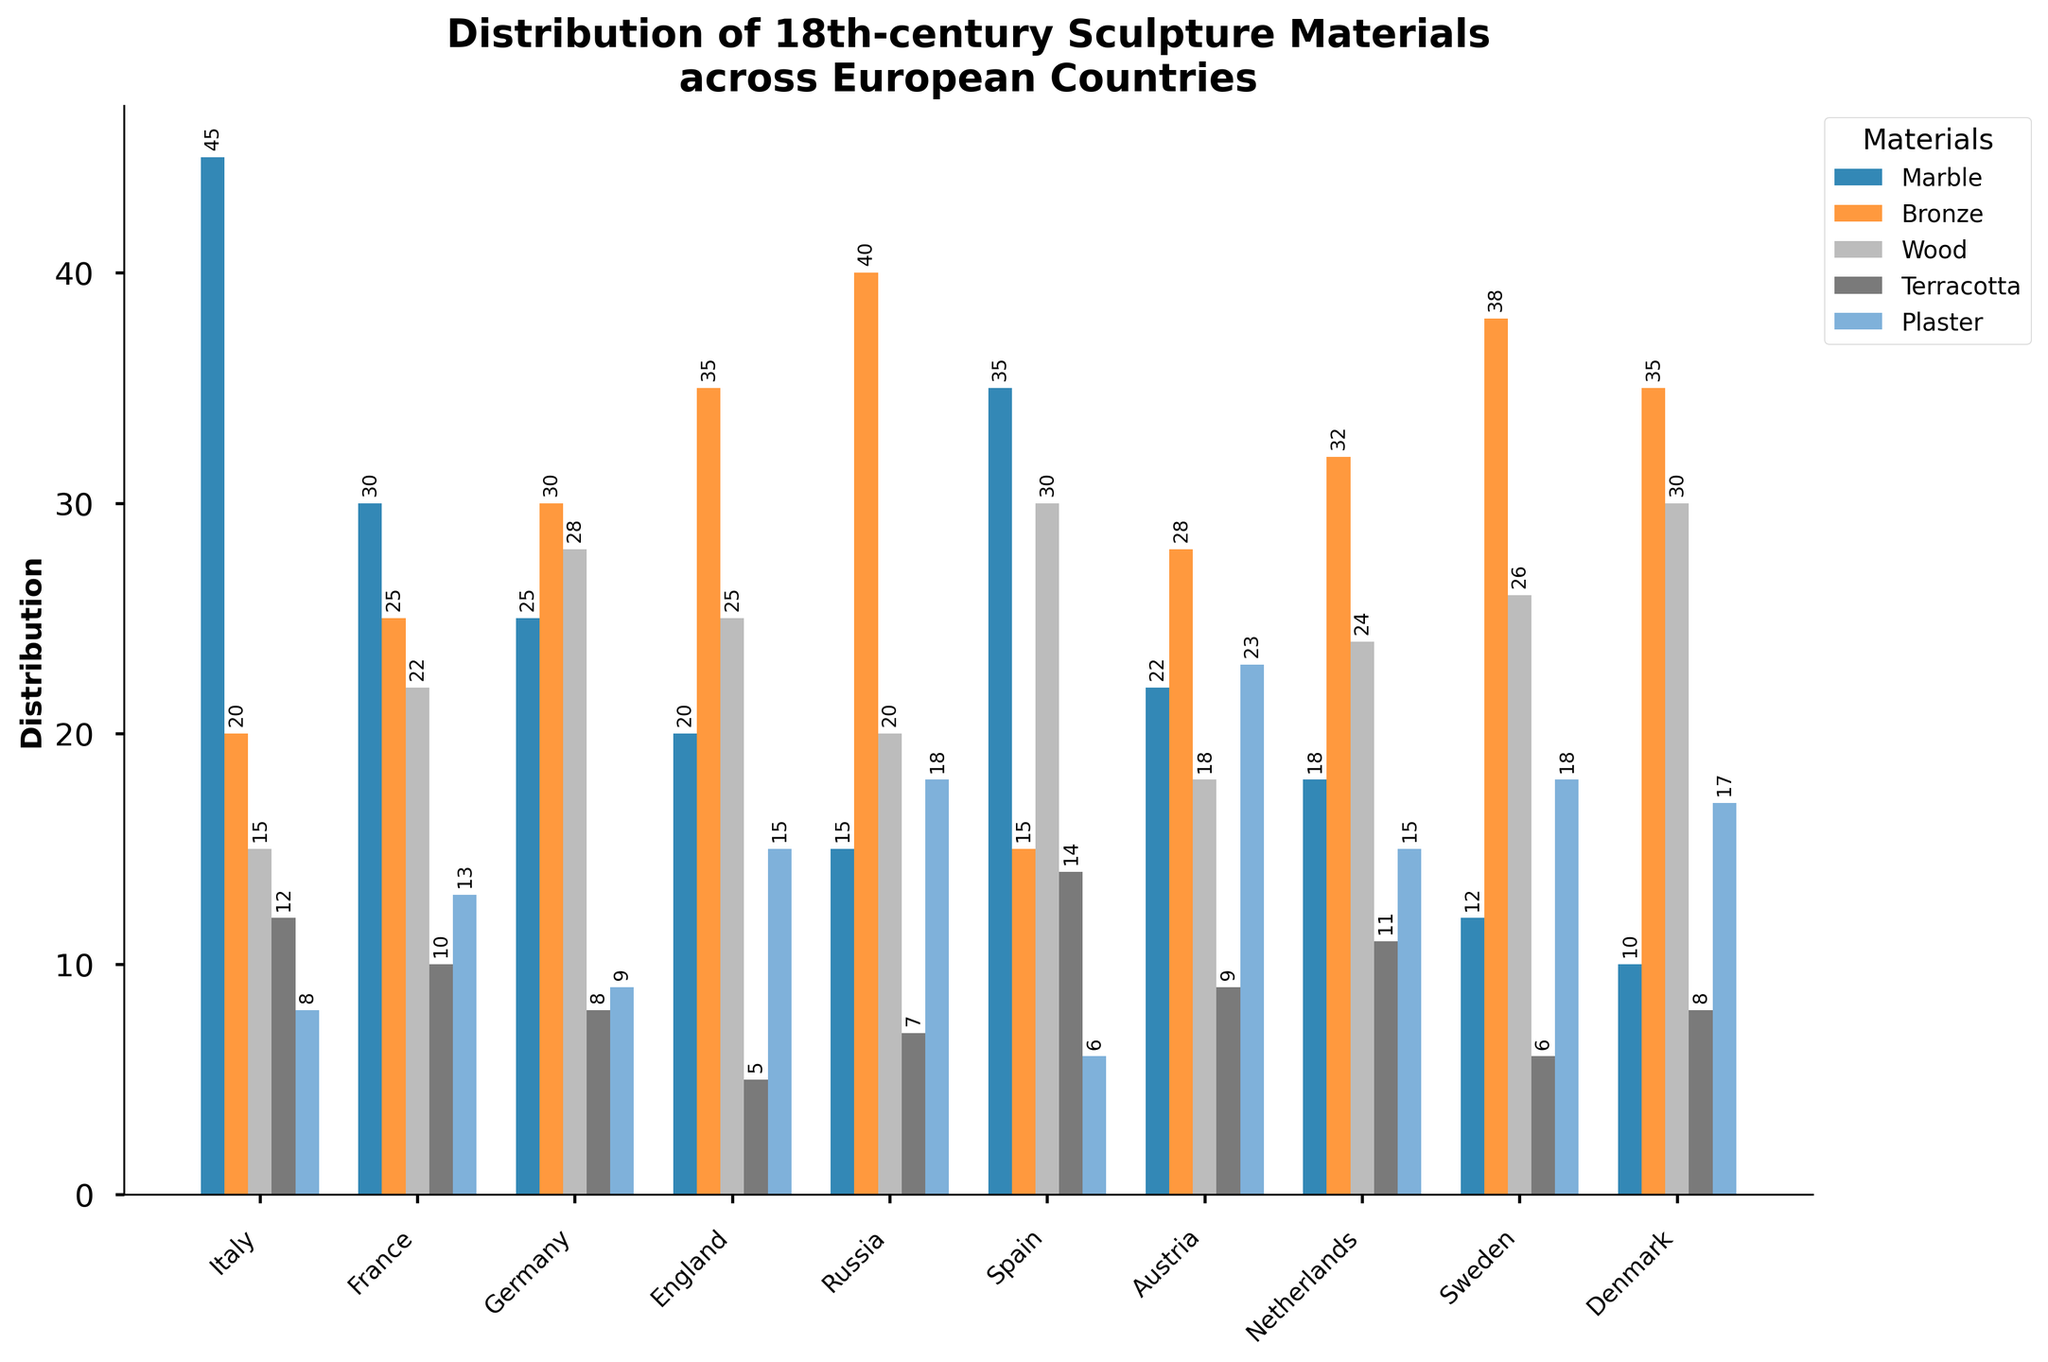What material was used the most in Russia? We look at the tallest bar within the Russia data point group. The tallest bar represents "Bronze," indicating the highest distribution in Russia.
Answer: Bronze Which country has the highest distribution of wood? We compare the height of the Wood section bars for each country. Germany has the tallest bar, indicating the highest distribution of wood.
Answer: Germany What is the sum of the distribution of marble in Italy and Spain? Add the marble distribution amounts for Italy (45) and Spain (35). The sum is 45 + 35.
Answer: 80 Which country has more bronze sculptures, France or England? Compare the height of the Bronze section bars for France and England. France has a bar of height 25, and England has a bar of height 35.
Answer: England What is the average distribution of terracotta for the Scandinavian countries (Denmark and Sweden)? We sum the terracotta distribution for Denmark (8) and Sweden (6) and divide by 2. The average is (8 + 6) / 2.
Answer: 7 Which material shows the most even distribution across all countries? We look at the general heights of the bars across all countries. At a glance, most materials except for "Marble" and "Bronze" appear varied. "Plaster" shows relatively even distribution without extreme highs or lows.
Answer: Plaster Is bronze distribution in Russia greater than marble distribution in Italy? Compare the height of the Bronze bar for Russia (40) with the height of the Marble bar for Italy (45). Russia's Bronze bar is slightly lower than Italy's Marble bar.
Answer: No Which two countries have the closest distribution of plaster? Find two countries whose plaster bars are of similar height. Austria and Sweden both have their Plaster distribution bars very close (23 and 18 respectively).
Answer: Austria and Sweden What is the total distribution of materials in France? Add the distribution amounts for all materials in France: 30 (Marble), 25 (Bronze), 22 (Wood), 10 (Terracotta), 13 (Plaster). The total is 30 + 25 + 22 + 10 + 13.
Answer: 100 Which country has the least overall distribution of sculpture materials? Sum up the distributions for each material for all countries and identify the minimal sum. The sums are: Italy (45+20+15+12+8=100), France (100), Germany (100), England (100), Russia (100), Spain (100), Austria (100), Netherlands (100), Sweden (100), Denmark (100). Italy has the overall least with a total of 100.
Answer: Italy 